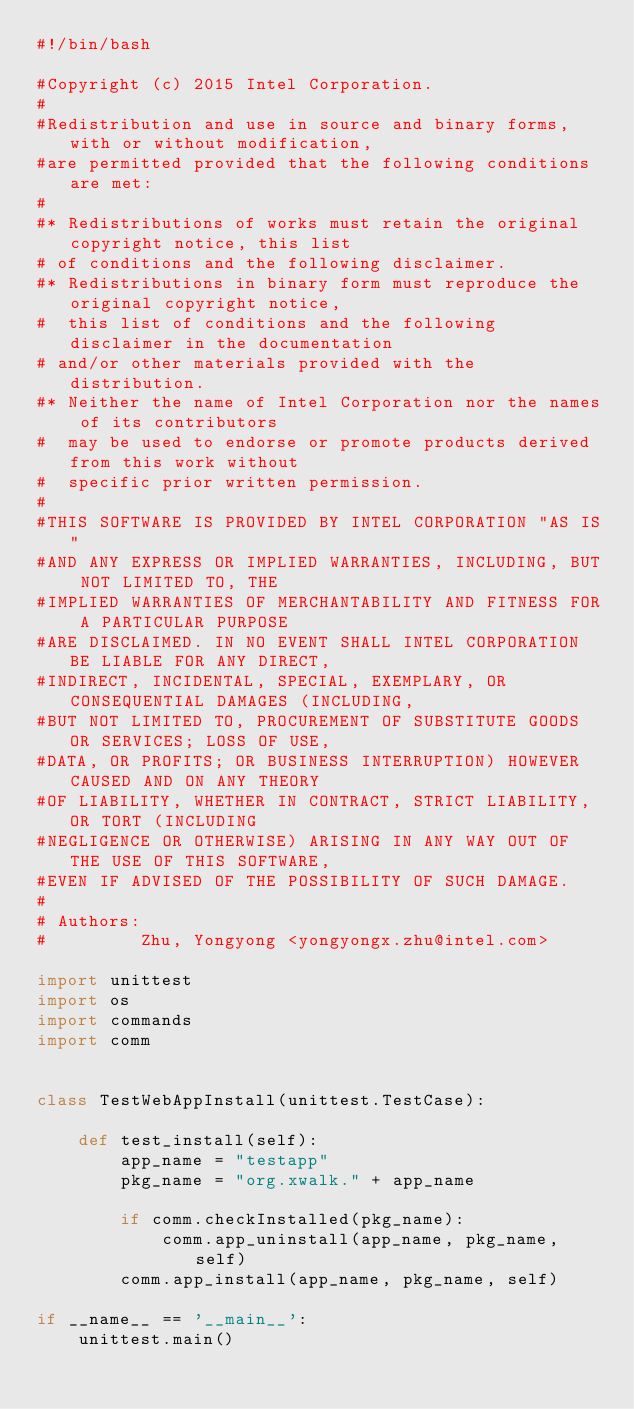<code> <loc_0><loc_0><loc_500><loc_500><_Python_>#!/bin/bash

#Copyright (c) 2015 Intel Corporation.
#
#Redistribution and use in source and binary forms, with or without modification,
#are permitted provided that the following conditions are met:
#
#* Redistributions of works must retain the original copyright notice, this list
# of conditions and the following disclaimer.
#* Redistributions in binary form must reproduce the original copyright notice,
#  this list of conditions and the following disclaimer in the documentation
# and/or other materials provided with the distribution.
#* Neither the name of Intel Corporation nor the names of its contributors
#  may be used to endorse or promote products derived from this work without
#  specific prior written permission.
#
#THIS SOFTWARE IS PROVIDED BY INTEL CORPORATION "AS IS"
#AND ANY EXPRESS OR IMPLIED WARRANTIES, INCLUDING, BUT NOT LIMITED TO, THE
#IMPLIED WARRANTIES OF MERCHANTABILITY AND FITNESS FOR A PARTICULAR PURPOSE
#ARE DISCLAIMED. IN NO EVENT SHALL INTEL CORPORATION BE LIABLE FOR ANY DIRECT,
#INDIRECT, INCIDENTAL, SPECIAL, EXEMPLARY, OR CONSEQUENTIAL DAMAGES (INCLUDING,
#BUT NOT LIMITED TO, PROCUREMENT OF SUBSTITUTE GOODS OR SERVICES; LOSS OF USE,
#DATA, OR PROFITS; OR BUSINESS INTERRUPTION) HOWEVER CAUSED AND ON ANY THEORY
#OF LIABILITY, WHETHER IN CONTRACT, STRICT LIABILITY, OR TORT (INCLUDING
#NEGLIGENCE OR OTHERWISE) ARISING IN ANY WAY OUT OF THE USE OF THIS SOFTWARE,
#EVEN IF ADVISED OF THE POSSIBILITY OF SUCH DAMAGE.
#
# Authors:
#         Zhu, Yongyong <yongyongx.zhu@intel.com>

import unittest
import os
import commands
import comm


class TestWebAppInstall(unittest.TestCase):

    def test_install(self):
        app_name = "testapp"
        pkg_name = "org.xwalk." + app_name

        if comm.checkInstalled(pkg_name):
            comm.app_uninstall(app_name, pkg_name, self)
        comm.app_install(app_name, pkg_name, self)

if __name__ == '__main__':
    unittest.main()
</code> 